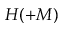Convert formula to latex. <formula><loc_0><loc_0><loc_500><loc_500>H ( + M )</formula> 